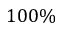Convert formula to latex. <formula><loc_0><loc_0><loc_500><loc_500>1 0 0 \%</formula> 